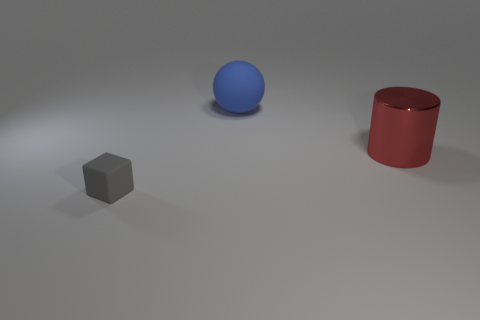Could you describe the lighting setup that was likely used to create the shadows we see here? The shadows on the surface suggest a single, coherent light source from the upper left of the frame. This is indicated by the way the shadows are cast at consistent angles away from the objects. The soft edges of the shadows imply the light source is not extremely close to the objects, providing a diffuse and soft lighting rather than a harsh, direct spotlight.  Judging by the image, what time of day could this represent if it were outdoors? If this were an outdoor scene, the angle and softness of the shadows might suggest early morning or late afternoon, when the sun is lower in the sky and casts longer, softer shadows. However, it's more likely that this is an artificial lighting setup meant to mimic such natural lighting conditions. 